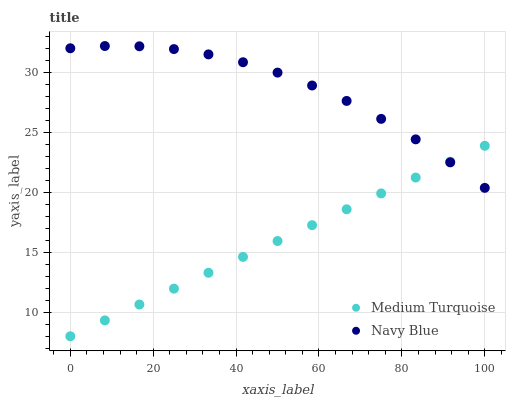Does Medium Turquoise have the minimum area under the curve?
Answer yes or no. Yes. Does Navy Blue have the maximum area under the curve?
Answer yes or no. Yes. Does Medium Turquoise have the maximum area under the curve?
Answer yes or no. No. Is Medium Turquoise the smoothest?
Answer yes or no. Yes. Is Navy Blue the roughest?
Answer yes or no. Yes. Is Medium Turquoise the roughest?
Answer yes or no. No. Does Medium Turquoise have the lowest value?
Answer yes or no. Yes. Does Navy Blue have the highest value?
Answer yes or no. Yes. Does Medium Turquoise have the highest value?
Answer yes or no. No. Does Medium Turquoise intersect Navy Blue?
Answer yes or no. Yes. Is Medium Turquoise less than Navy Blue?
Answer yes or no. No. Is Medium Turquoise greater than Navy Blue?
Answer yes or no. No. 